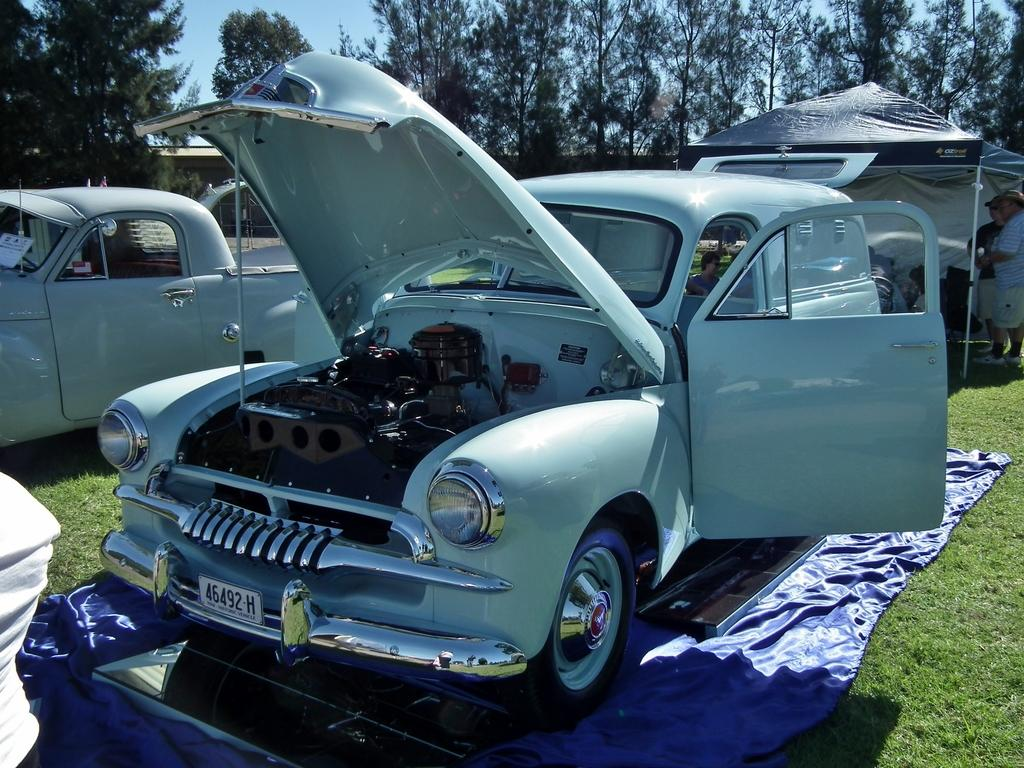What type of vegetation is present in the image? There is grass in the image. What is placed under the car in the image? There is a blue color cloth under the car. How many cars are visible in the image? There are cars in the image. What can be seen in the background of the image? There is a tent and trees in the background of the image. Are there any people present in the image? Yes, there are people in the image. What letter is being used to play a game with the people in the image? There is no letter or game being played in the image; it features grass, a blue cloth under a car, cars, a tent and trees in the background, and people. What type of ring can be seen on the tent in the image? There is no ring present on the tent or any other object in the image. 